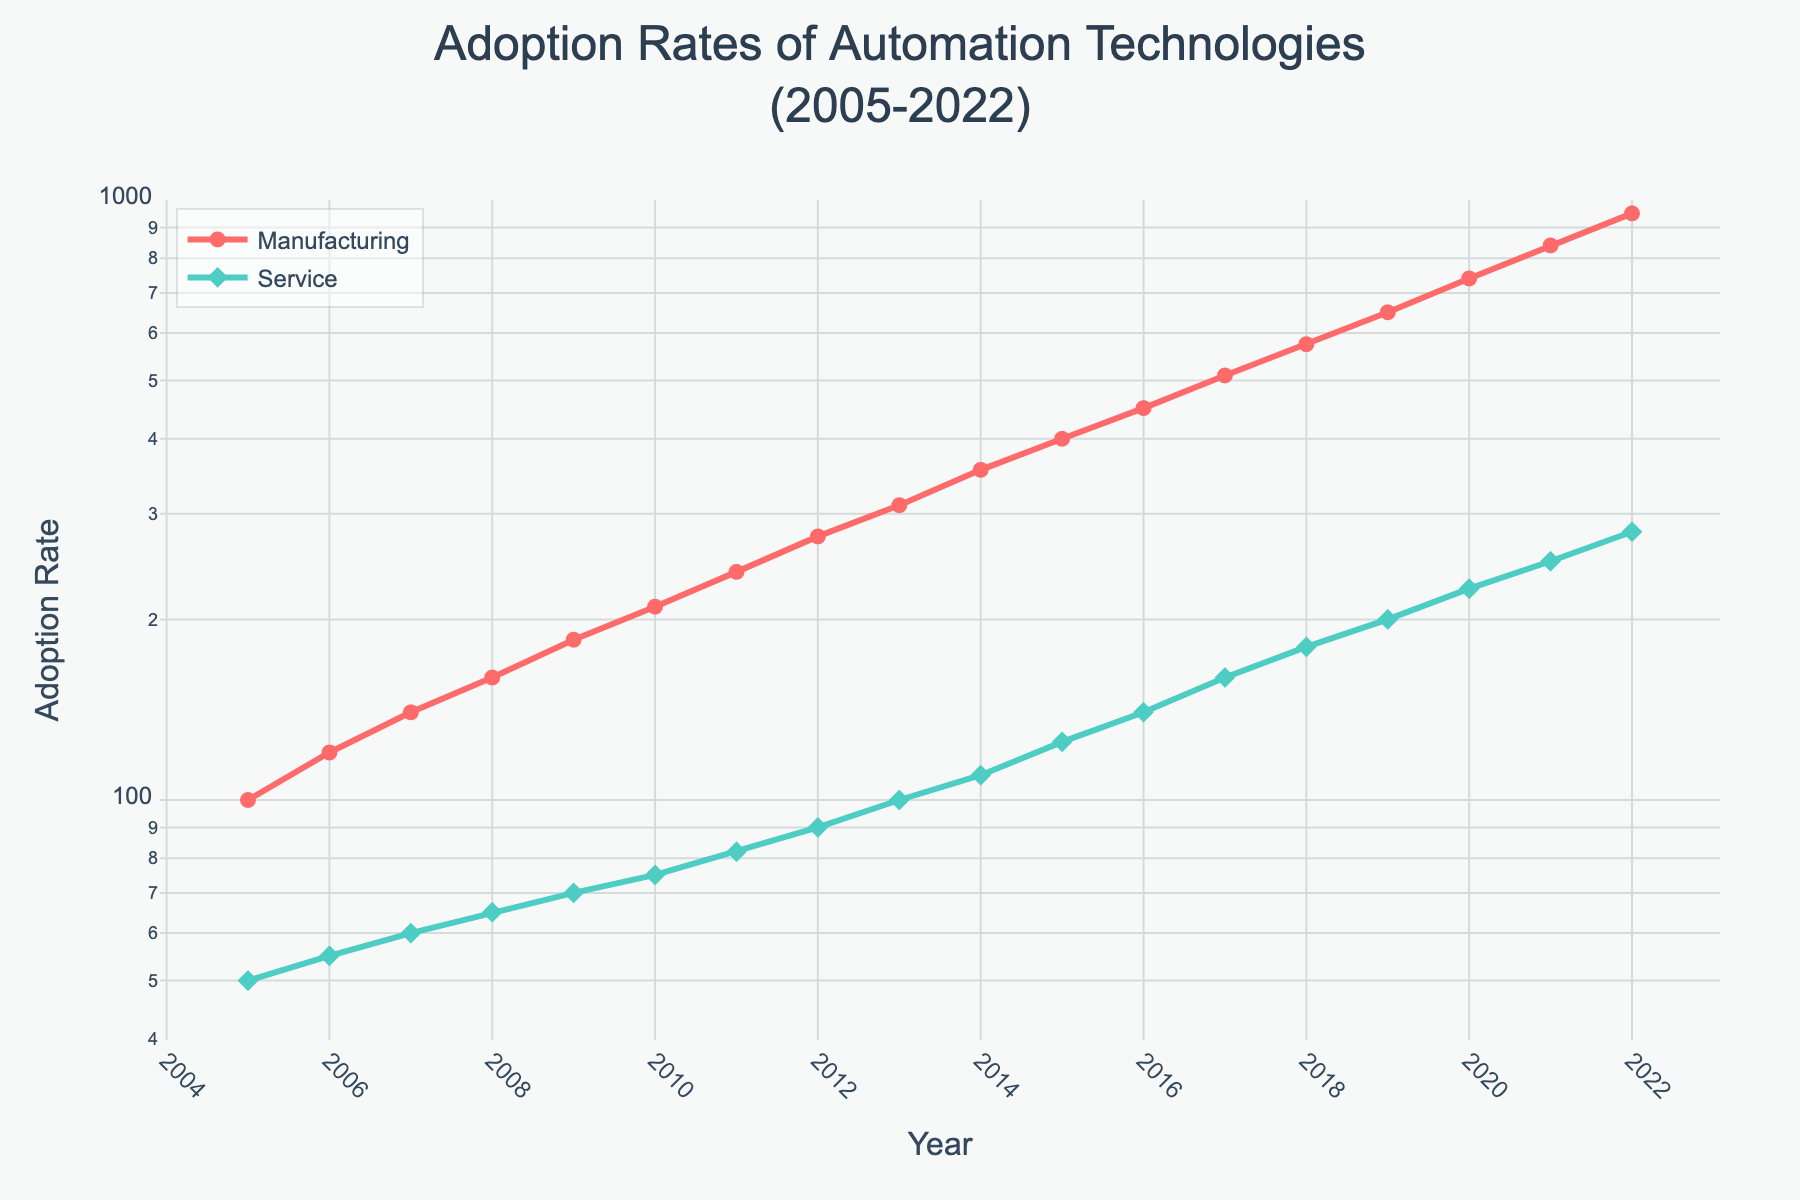What is the title of the figure? The title is typically at the top of the figure and provides a brief description of what the plot represents. It mentions the time frame and the subject of the data.
Answer: Adoption Rates of Automation Technologies (2005-2022) What is the y-axis labeled as? The y-axis label is generally situated along the vertical axis, indicating what the y-values represent in the plot.
Answer: Adoption Rate What color represents the Manufacturing data in the plot? The color used for the Manufacturing line and markers can be observed in the legend and chart itself.
Answer: Red What is the adoption rate for the Service industry in 2011? Locate the year 2011 on the x-axis, then look up to the 'Service' line and marker to find the corresponding y-axis value.
Answer: 82 Between which two consecutive years did the Manufacturing industry see the highest increase in adoption rate? Observe the 'Manufacturing' line, identify the steepest incline between two consecutive years by comparing the slopes visually.
Answer: 2021 and 2022 How does the adoption rate in 2015 for the Manufacturing industry compare to that for the Service industry? To compare the two values from 2015, find the y-values for both 'Manufacturing' and 'Service' at that year and then compare them.
Answer: Manufacturing is higher By what factor did the adoption rate in the Service industry increase from 2010 to 2022? Locate the adoption rates for 2010 and 2022 on the y-axis for the Service industry, then divide the latter by the former to find the multiplication factor.
Answer: 3.73 Which year shows the adoption rate for Service industry crossing the 100 mark? Follow the 'Service' line upwards along the y-axis until it crosses the 100 mark, then find the corresponding year on the x-axis.
Answer: 2013 In which year did the Manufacturing industry adoption rate first reach 210? Locate the point where the 'Manufacturing' line first intersects the 210 mark on the y-axis and then match it to the corresponding year on the x-axis.
Answer: 2010 What trend can be observed in the adoption rate of the Manufacturing industry from 2005 to 2022? By examining the 'Manufacturing' line over the entire time span, observe the general direction and pattern of the trend.
Answer: Increasing trend 